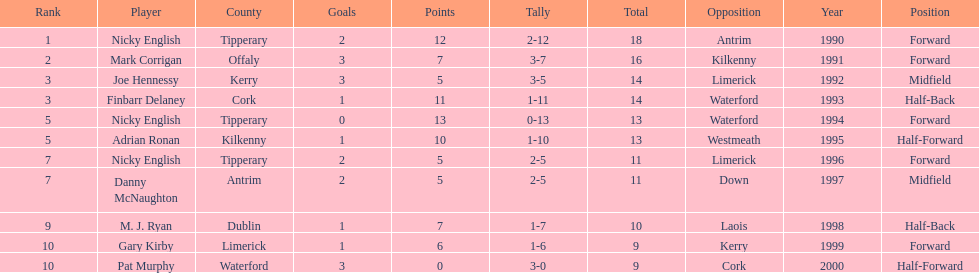Can you parse all the data within this table? {'header': ['Rank', 'Player', 'County', 'Goals', 'Points', 'Tally', 'Total', 'Opposition', 'Year', 'Position'], 'rows': [['1', 'Nicky English', 'Tipperary', '2', '12', '2-12', '18', 'Antrim', '1990', 'Forward'], ['2', 'Mark Corrigan', 'Offaly', '3', '7', '3-7', '16', 'Kilkenny', '1991', 'Forward'], ['3', 'Joe Hennessy', 'Kerry', '3', '5', '3-5', '14', 'Limerick', '1992', 'Midfield'], ['3', 'Finbarr Delaney', 'Cork', '1', '11', '1-11', '14', 'Waterford', '1993', 'Half-Back'], ['5', 'Nicky English', 'Tipperary', '0', '13', '0-13', '13', 'Waterford', '1994', 'Forward'], ['5', 'Adrian Ronan', 'Kilkenny', '1', '10', '1-10', '13', 'Westmeath', '1995', 'Half-Forward'], ['7', 'Nicky English', 'Tipperary', '2', '5', '2-5', '11', 'Limerick', '1996', 'Forward'], ['7', 'Danny McNaughton', 'Antrim', '2', '5', '2-5', '11', 'Down', '1997', 'Midfield'], ['9', 'M. J. Ryan', 'Dublin', '1', '7', '1-7', '10', 'Laois', '1998', 'Half-Back'], ['10', 'Gary Kirby', 'Limerick', '1', '6', '1-6', '9', 'Kerry', '1999', 'Forward'], ['10', 'Pat Murphy', 'Waterford', '3', '0', '3-0', '9', 'Cork', '2000', 'Half-Forward']]} If you added all the total's up, what would the number be? 138. 